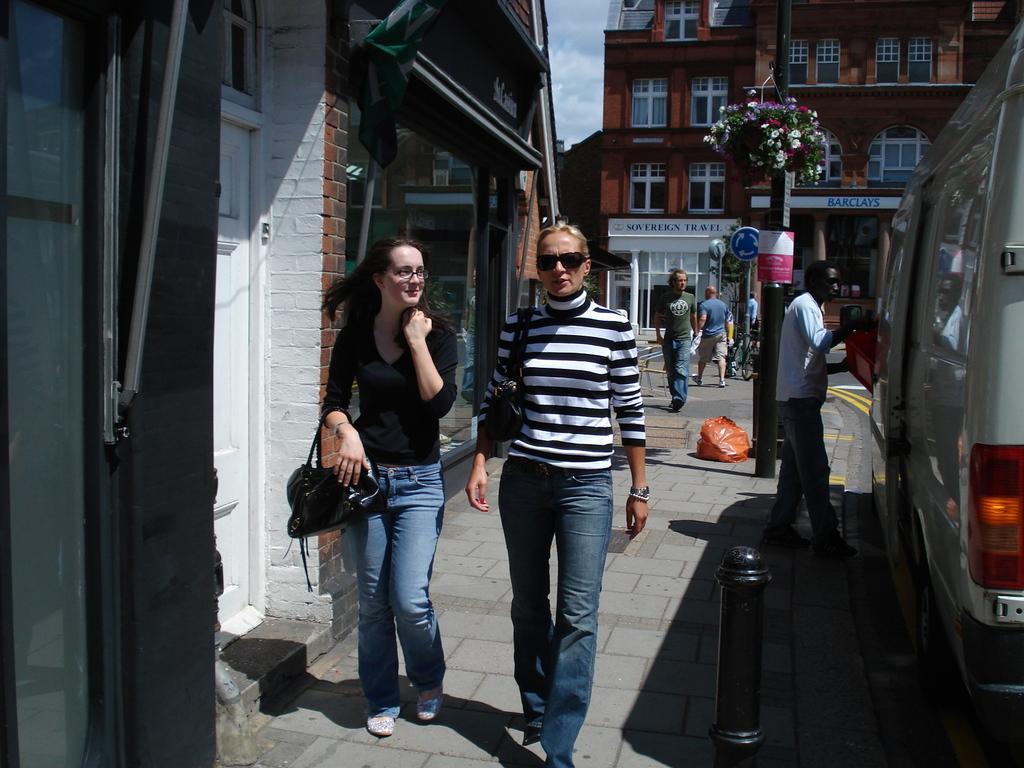How would you summarize this image in a sentence or two? In the middle of the image few people are walking on the road. In the middle of the image there is a pole and there are some flowers. Bottom right side of the image there is a vehicle behind the vehicle there is a building. At the top of the image there are some clouds. 